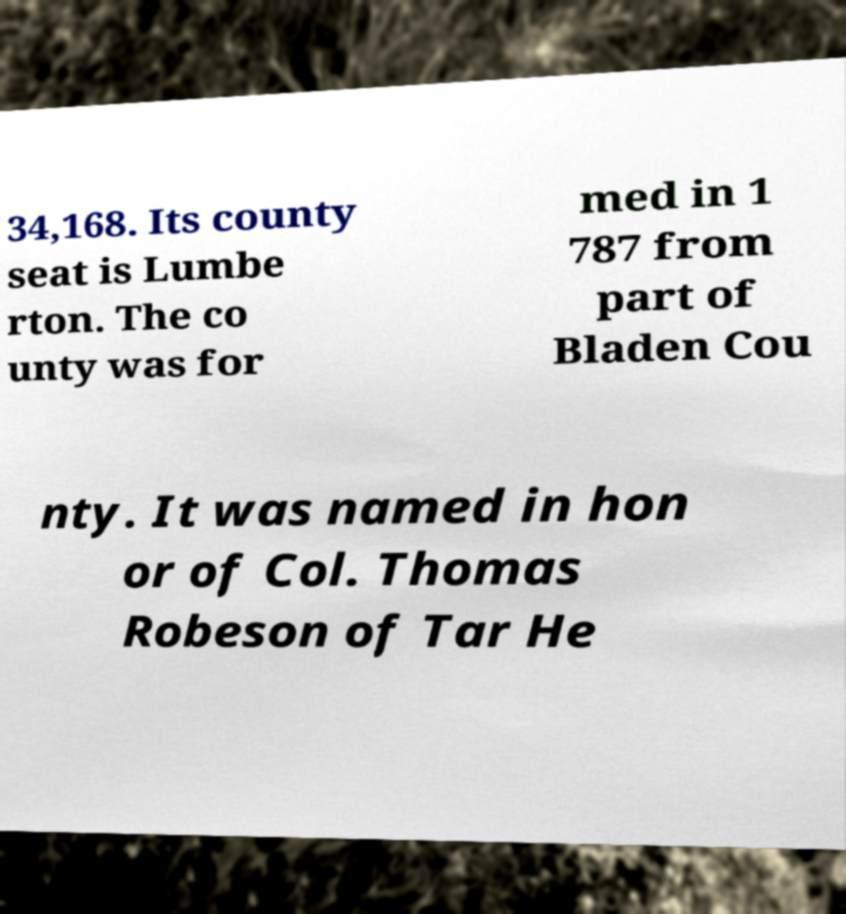Please read and relay the text visible in this image. What does it say? 34,168. Its county seat is Lumbe rton. The co unty was for med in 1 787 from part of Bladen Cou nty. It was named in hon or of Col. Thomas Robeson of Tar He 